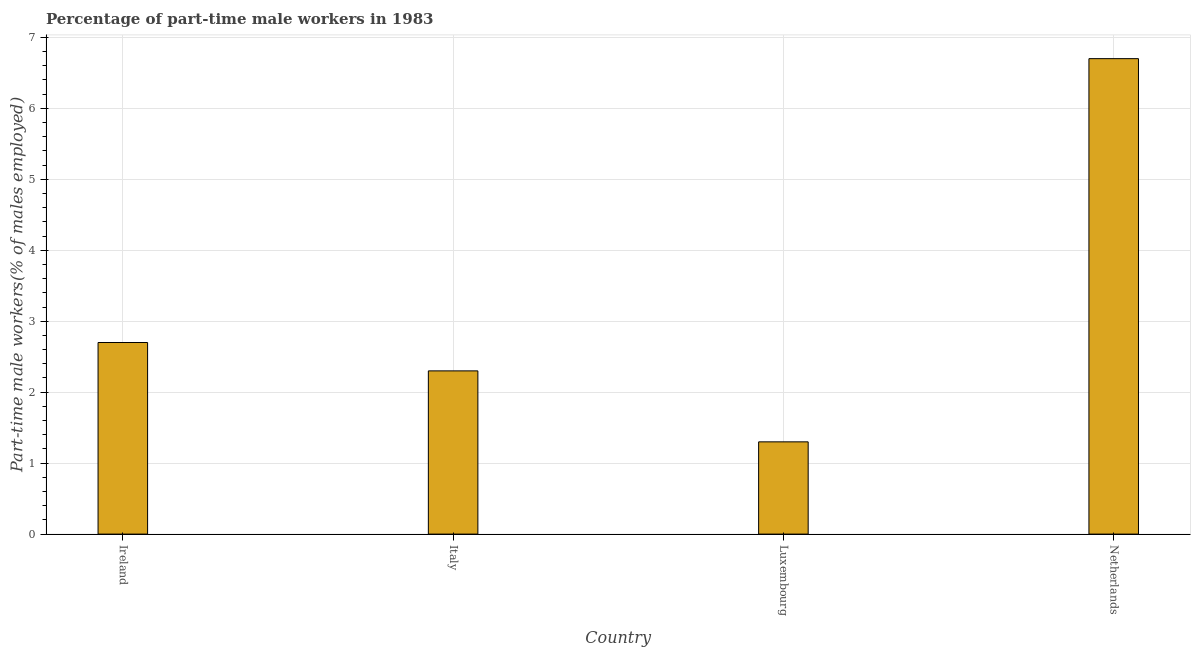Does the graph contain any zero values?
Your answer should be very brief. No. What is the title of the graph?
Your response must be concise. Percentage of part-time male workers in 1983. What is the label or title of the X-axis?
Give a very brief answer. Country. What is the label or title of the Y-axis?
Offer a terse response. Part-time male workers(% of males employed). What is the percentage of part-time male workers in Ireland?
Offer a terse response. 2.7. Across all countries, what is the maximum percentage of part-time male workers?
Offer a very short reply. 6.7. Across all countries, what is the minimum percentage of part-time male workers?
Keep it short and to the point. 1.3. In which country was the percentage of part-time male workers maximum?
Ensure brevity in your answer.  Netherlands. In which country was the percentage of part-time male workers minimum?
Provide a short and direct response. Luxembourg. What is the sum of the percentage of part-time male workers?
Your response must be concise. 13. What is the difference between the percentage of part-time male workers in Italy and Netherlands?
Offer a very short reply. -4.4. What is the median percentage of part-time male workers?
Your response must be concise. 2.5. In how many countries, is the percentage of part-time male workers greater than 4.4 %?
Offer a very short reply. 1. What is the ratio of the percentage of part-time male workers in Italy to that in Netherlands?
Offer a very short reply. 0.34. Is the percentage of part-time male workers in Luxembourg less than that in Netherlands?
Your response must be concise. Yes. What is the difference between the highest and the second highest percentage of part-time male workers?
Your answer should be compact. 4. Is the sum of the percentage of part-time male workers in Ireland and Netherlands greater than the maximum percentage of part-time male workers across all countries?
Make the answer very short. Yes. What is the difference between the highest and the lowest percentage of part-time male workers?
Give a very brief answer. 5.4. In how many countries, is the percentage of part-time male workers greater than the average percentage of part-time male workers taken over all countries?
Ensure brevity in your answer.  1. Are all the bars in the graph horizontal?
Make the answer very short. No. Are the values on the major ticks of Y-axis written in scientific E-notation?
Your answer should be very brief. No. What is the Part-time male workers(% of males employed) in Ireland?
Your response must be concise. 2.7. What is the Part-time male workers(% of males employed) of Italy?
Provide a short and direct response. 2.3. What is the Part-time male workers(% of males employed) of Luxembourg?
Provide a succinct answer. 1.3. What is the Part-time male workers(% of males employed) of Netherlands?
Provide a succinct answer. 6.7. What is the difference between the Part-time male workers(% of males employed) in Ireland and Italy?
Offer a terse response. 0.4. What is the difference between the Part-time male workers(% of males employed) in Luxembourg and Netherlands?
Your response must be concise. -5.4. What is the ratio of the Part-time male workers(% of males employed) in Ireland to that in Italy?
Offer a terse response. 1.17. What is the ratio of the Part-time male workers(% of males employed) in Ireland to that in Luxembourg?
Your answer should be compact. 2.08. What is the ratio of the Part-time male workers(% of males employed) in Ireland to that in Netherlands?
Your answer should be compact. 0.4. What is the ratio of the Part-time male workers(% of males employed) in Italy to that in Luxembourg?
Give a very brief answer. 1.77. What is the ratio of the Part-time male workers(% of males employed) in Italy to that in Netherlands?
Ensure brevity in your answer.  0.34. What is the ratio of the Part-time male workers(% of males employed) in Luxembourg to that in Netherlands?
Keep it short and to the point. 0.19. 